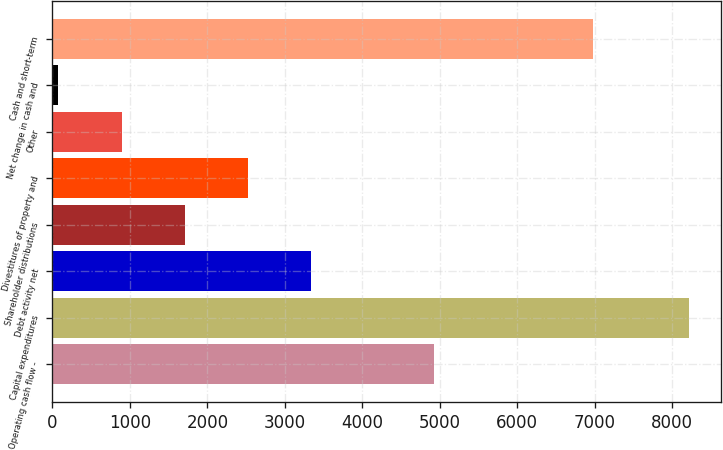<chart> <loc_0><loc_0><loc_500><loc_500><bar_chart><fcel>Operating cash flow -<fcel>Capital expenditures<fcel>Debt activity net<fcel>Shareholder distributions<fcel>Divestitures of property and<fcel>Other<fcel>Net change in cash and<fcel>Cash and short-term<nl><fcel>4930<fcel>8225<fcel>3336.8<fcel>1707.4<fcel>2522.1<fcel>892.7<fcel>78<fcel>6980<nl></chart> 